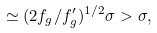<formula> <loc_0><loc_0><loc_500><loc_500>\simeq ( 2 f _ { g } / f ^ { \prime } _ { g } ) ^ { 1 / 2 } \sigma > \sigma ,</formula> 